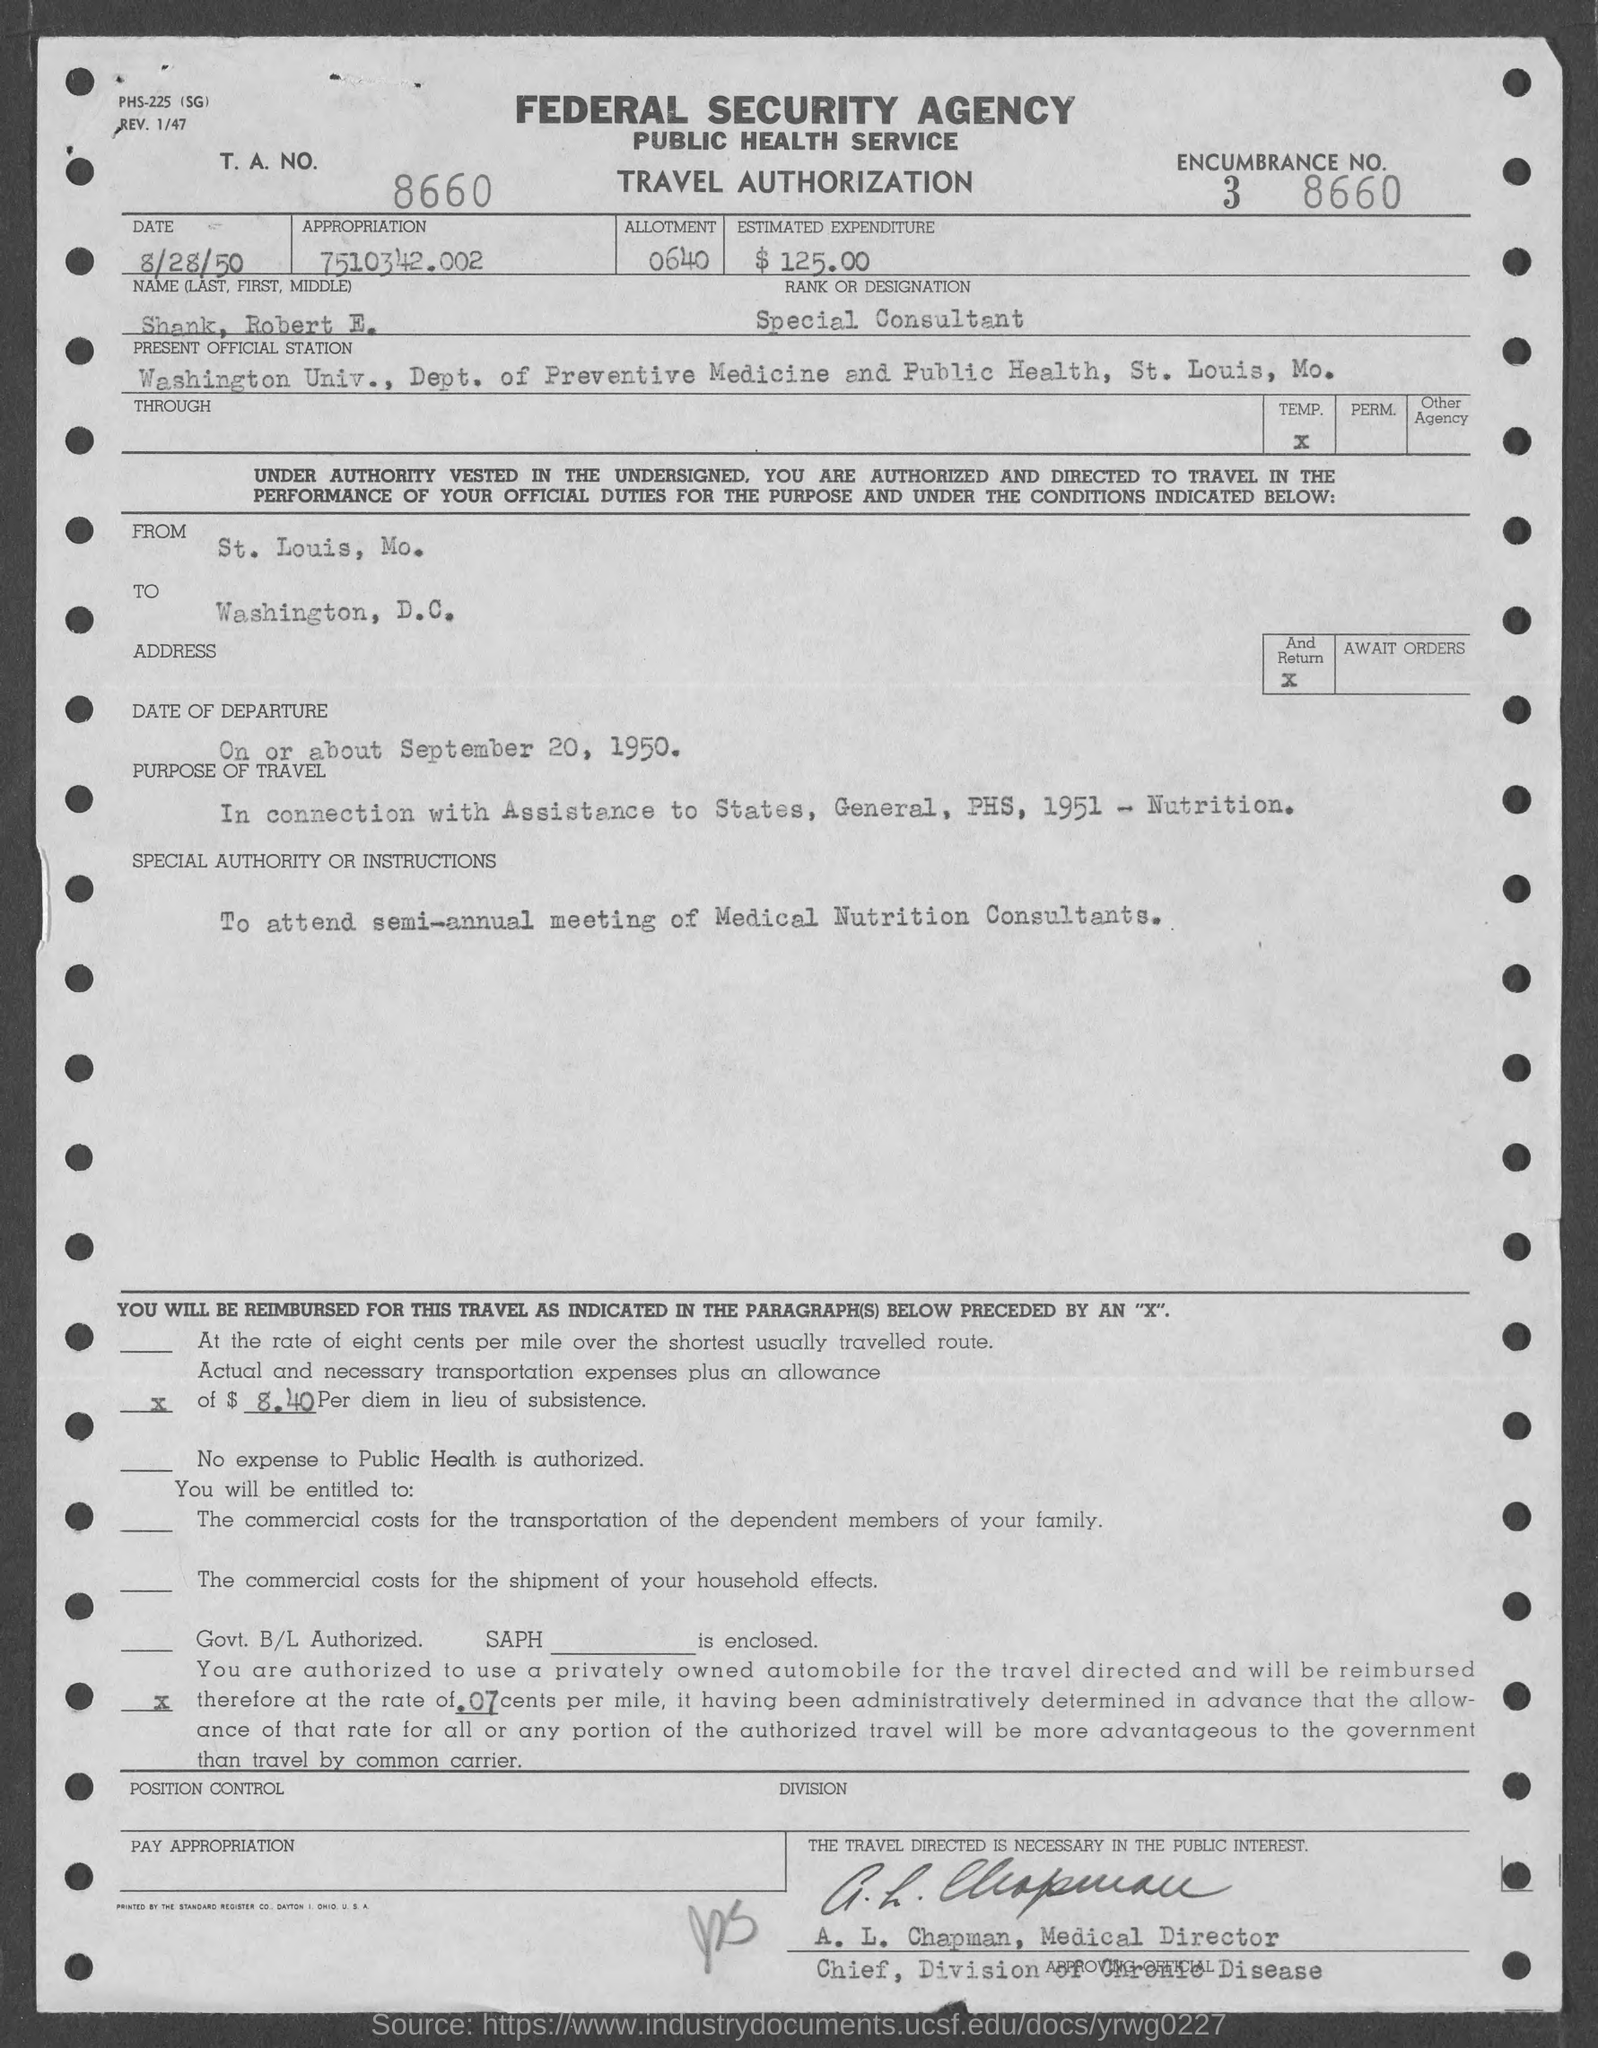List a handful of essential elements in this visual. The date mentioned at the top of this document is August 28, 1950. The Allotment Number is 0640. The estimated expenditure is $125.00. Shank has been designated as a special consultant. The ENCUMBERANCE number is 3 and it is represented as 8660.. 